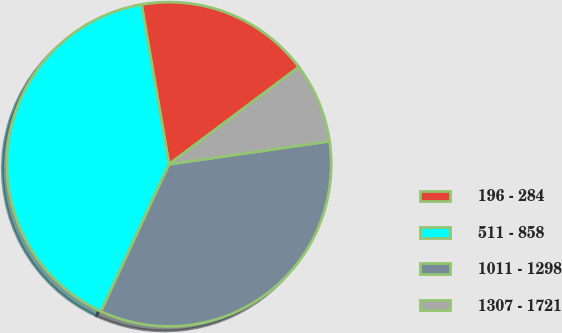Convert chart. <chart><loc_0><loc_0><loc_500><loc_500><pie_chart><fcel>196 - 284<fcel>511 - 858<fcel>1011 - 1298<fcel>1307 - 1721<nl><fcel>17.48%<fcel>40.39%<fcel>34.17%<fcel>7.96%<nl></chart> 